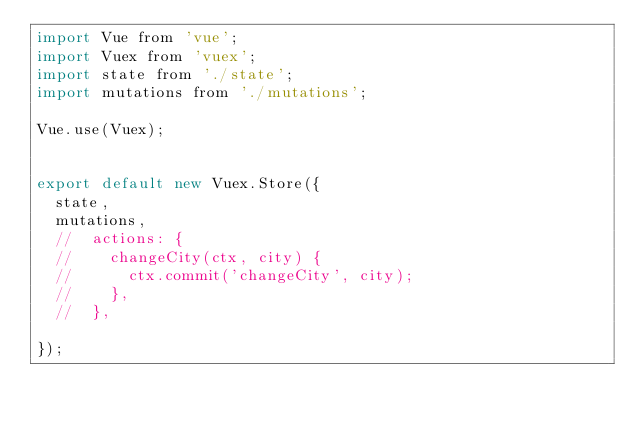Convert code to text. <code><loc_0><loc_0><loc_500><loc_500><_JavaScript_>import Vue from 'vue';
import Vuex from 'vuex';
import state from './state';
import mutations from './mutations';

Vue.use(Vuex);


export default new Vuex.Store({
  state,
  mutations,
  //  actions: {
  //    changeCity(ctx, city) {
  //      ctx.commit('changeCity', city);
  //    },
  //  },

});
</code> 